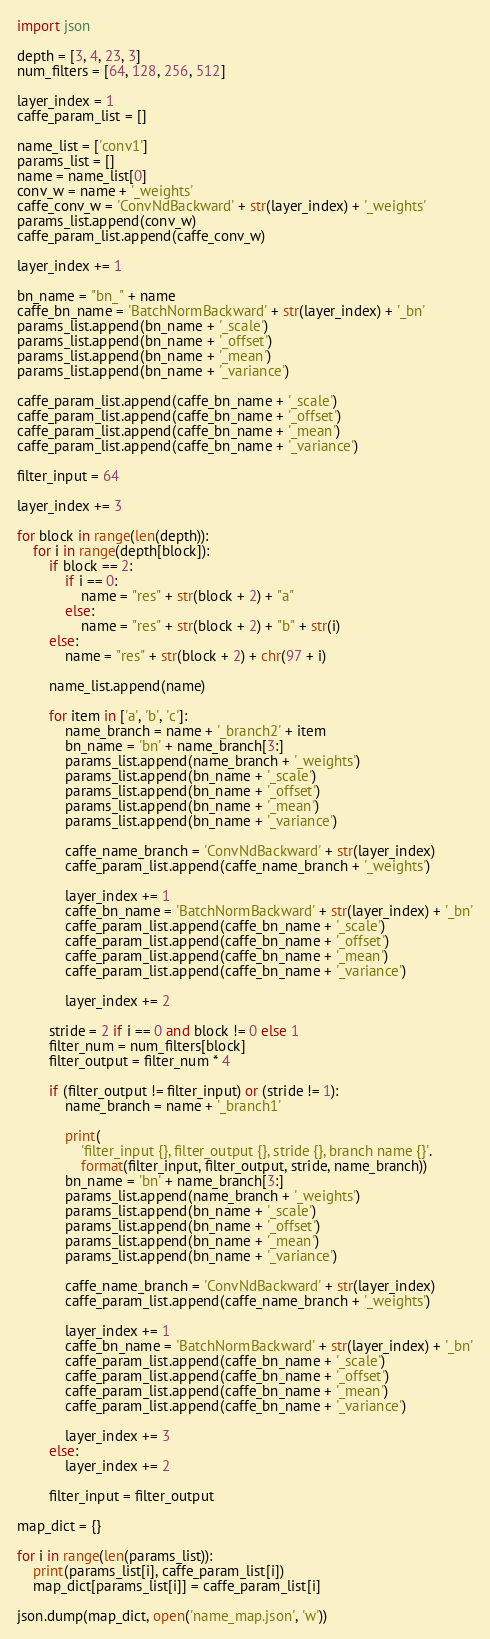<code> <loc_0><loc_0><loc_500><loc_500><_Python_>import json

depth = [3, 4, 23, 3]
num_filters = [64, 128, 256, 512]

layer_index = 1
caffe_param_list = []

name_list = ['conv1']
params_list = []
name = name_list[0]
conv_w = name + '_weights'
caffe_conv_w = 'ConvNdBackward' + str(layer_index) + '_weights'
params_list.append(conv_w)
caffe_param_list.append(caffe_conv_w)

layer_index += 1

bn_name = "bn_" + name
caffe_bn_name = 'BatchNormBackward' + str(layer_index) + '_bn'
params_list.append(bn_name + '_scale')
params_list.append(bn_name + '_offset')
params_list.append(bn_name + '_mean')
params_list.append(bn_name + '_variance')

caffe_param_list.append(caffe_bn_name + '_scale')
caffe_param_list.append(caffe_bn_name + '_offset')
caffe_param_list.append(caffe_bn_name + '_mean')
caffe_param_list.append(caffe_bn_name + '_variance')

filter_input = 64

layer_index += 3

for block in range(len(depth)):
    for i in range(depth[block]):
        if block == 2:
            if i == 0:
                name = "res" + str(block + 2) + "a"
            else:
                name = "res" + str(block + 2) + "b" + str(i)
        else:
            name = "res" + str(block + 2) + chr(97 + i)

        name_list.append(name)

        for item in ['a', 'b', 'c']:
            name_branch = name + '_branch2' + item
            bn_name = 'bn' + name_branch[3:]
            params_list.append(name_branch + '_weights')
            params_list.append(bn_name + '_scale')
            params_list.append(bn_name + '_offset')
            params_list.append(bn_name + '_mean')
            params_list.append(bn_name + '_variance')

            caffe_name_branch = 'ConvNdBackward' + str(layer_index)
            caffe_param_list.append(caffe_name_branch + '_weights')

            layer_index += 1
            caffe_bn_name = 'BatchNormBackward' + str(layer_index) + '_bn'
            caffe_param_list.append(caffe_bn_name + '_scale')
            caffe_param_list.append(caffe_bn_name + '_offset')
            caffe_param_list.append(caffe_bn_name + '_mean')
            caffe_param_list.append(caffe_bn_name + '_variance')

            layer_index += 2

        stride = 2 if i == 0 and block != 0 else 1
        filter_num = num_filters[block]
        filter_output = filter_num * 4

        if (filter_output != filter_input) or (stride != 1):
            name_branch = name + '_branch1'

            print(
                'filter_input {}, filter_output {}, stride {}, branch name {}'.
                format(filter_input, filter_output, stride, name_branch))
            bn_name = 'bn' + name_branch[3:]
            params_list.append(name_branch + '_weights')
            params_list.append(bn_name + '_scale')
            params_list.append(bn_name + '_offset')
            params_list.append(bn_name + '_mean')
            params_list.append(bn_name + '_variance')

            caffe_name_branch = 'ConvNdBackward' + str(layer_index)
            caffe_param_list.append(caffe_name_branch + '_weights')

            layer_index += 1
            caffe_bn_name = 'BatchNormBackward' + str(layer_index) + '_bn'
            caffe_param_list.append(caffe_bn_name + '_scale')
            caffe_param_list.append(caffe_bn_name + '_offset')
            caffe_param_list.append(caffe_bn_name + '_mean')
            caffe_param_list.append(caffe_bn_name + '_variance')

            layer_index += 3
        else:
            layer_index += 2

        filter_input = filter_output

map_dict = {}

for i in range(len(params_list)):
    print(params_list[i], caffe_param_list[i])
    map_dict[params_list[i]] = caffe_param_list[i]

json.dump(map_dict, open('name_map.json', 'w'))
</code> 